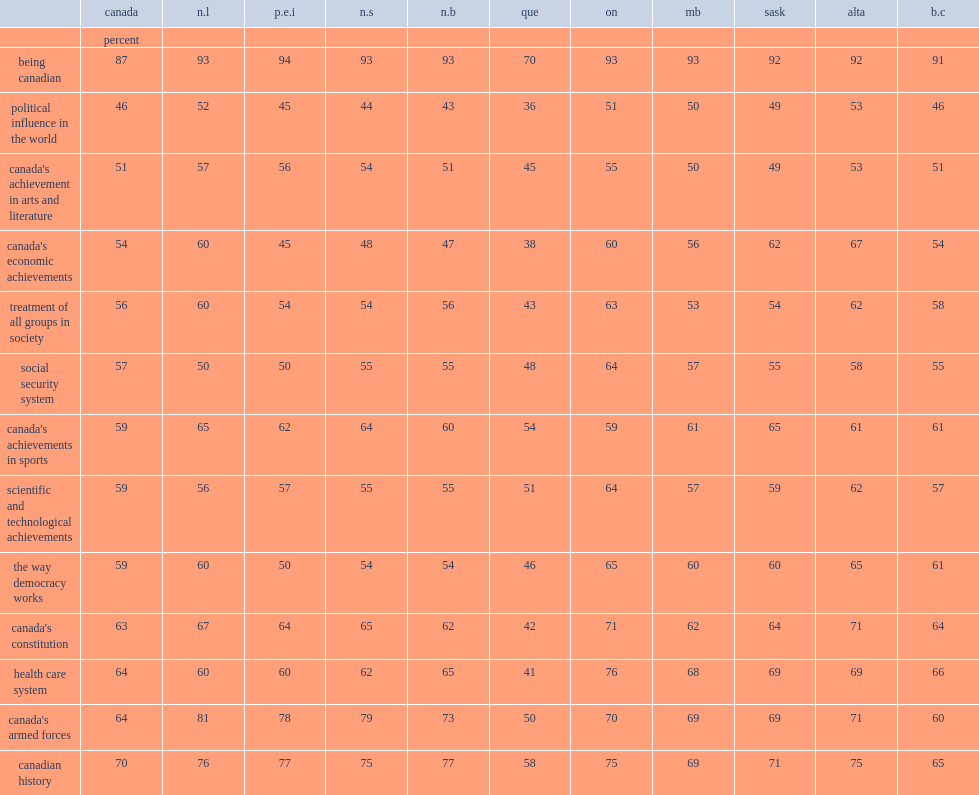In quebec, what percent described being proud or very proud in being canadian? 70. What percent of quebecers felt proud or very proud of canadian history? 58. What percent of quebecers felt proud or very proud of canada's political influence on the world? 36. What percent of albertans were proud of canada's economic achievements? 67. Parse the full table. {'header': ['', 'canada', 'n.l', 'p.e.i', 'n.s', 'n.b', 'que', 'on', 'mb', 'sask', 'alta', 'b.c'], 'rows': [['', 'percent', '', '', '', '', '', '', '', '', '', ''], ['being canadian', '87', '93', '94', '93', '93', '70', '93', '93', '92', '92', '91'], ['political influence in the world', '46', '52', '45', '44', '43', '36', '51', '50', '49', '53', '46'], ["canada's achievement in arts and literature", '51', '57', '56', '54', '51', '45', '55', '50', '49', '53', '51'], ["canada's economic achievements", '54', '60', '45', '48', '47', '38', '60', '56', '62', '67', '54'], ['treatment of all groups in society', '56', '60', '54', '54', '56', '43', '63', '53', '54', '62', '58'], ['social security system', '57', '50', '50', '55', '55', '48', '64', '57', '55', '58', '55'], ["canada's achievements in sports", '59', '65', '62', '64', '60', '54', '59', '61', '65', '61', '61'], ['scientific and technological achievements', '59', '56', '57', '55', '55', '51', '64', '57', '59', '62', '57'], ['the way democracy works', '59', '60', '50', '54', '54', '46', '65', '60', '60', '65', '61'], ["canada's constitution", '63', '67', '64', '65', '62', '42', '71', '62', '64', '71', '64'], ['health care system', '64', '60', '60', '62', '65', '41', '76', '68', '69', '69', '66'], ["canada's armed forces", '64', '81', '78', '79', '73', '50', '70', '69', '69', '71', '60'], ['canadian history', '70', '76', '77', '75', '77', '58', '75', '69', '71', '75', '65']]} 